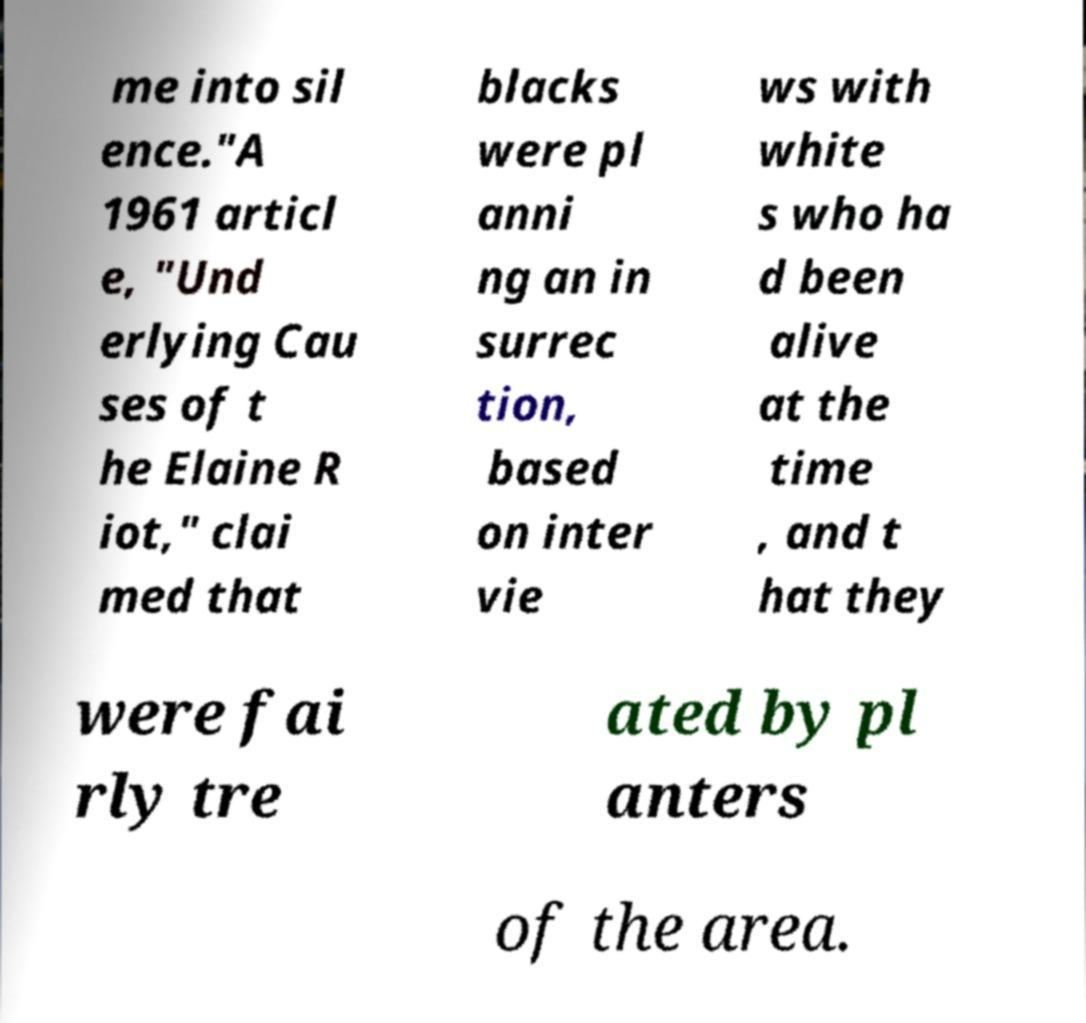Please identify and transcribe the text found in this image. me into sil ence."A 1961 articl e, "Und erlying Cau ses of t he Elaine R iot," clai med that blacks were pl anni ng an in surrec tion, based on inter vie ws with white s who ha d been alive at the time , and t hat they were fai rly tre ated by pl anters of the area. 